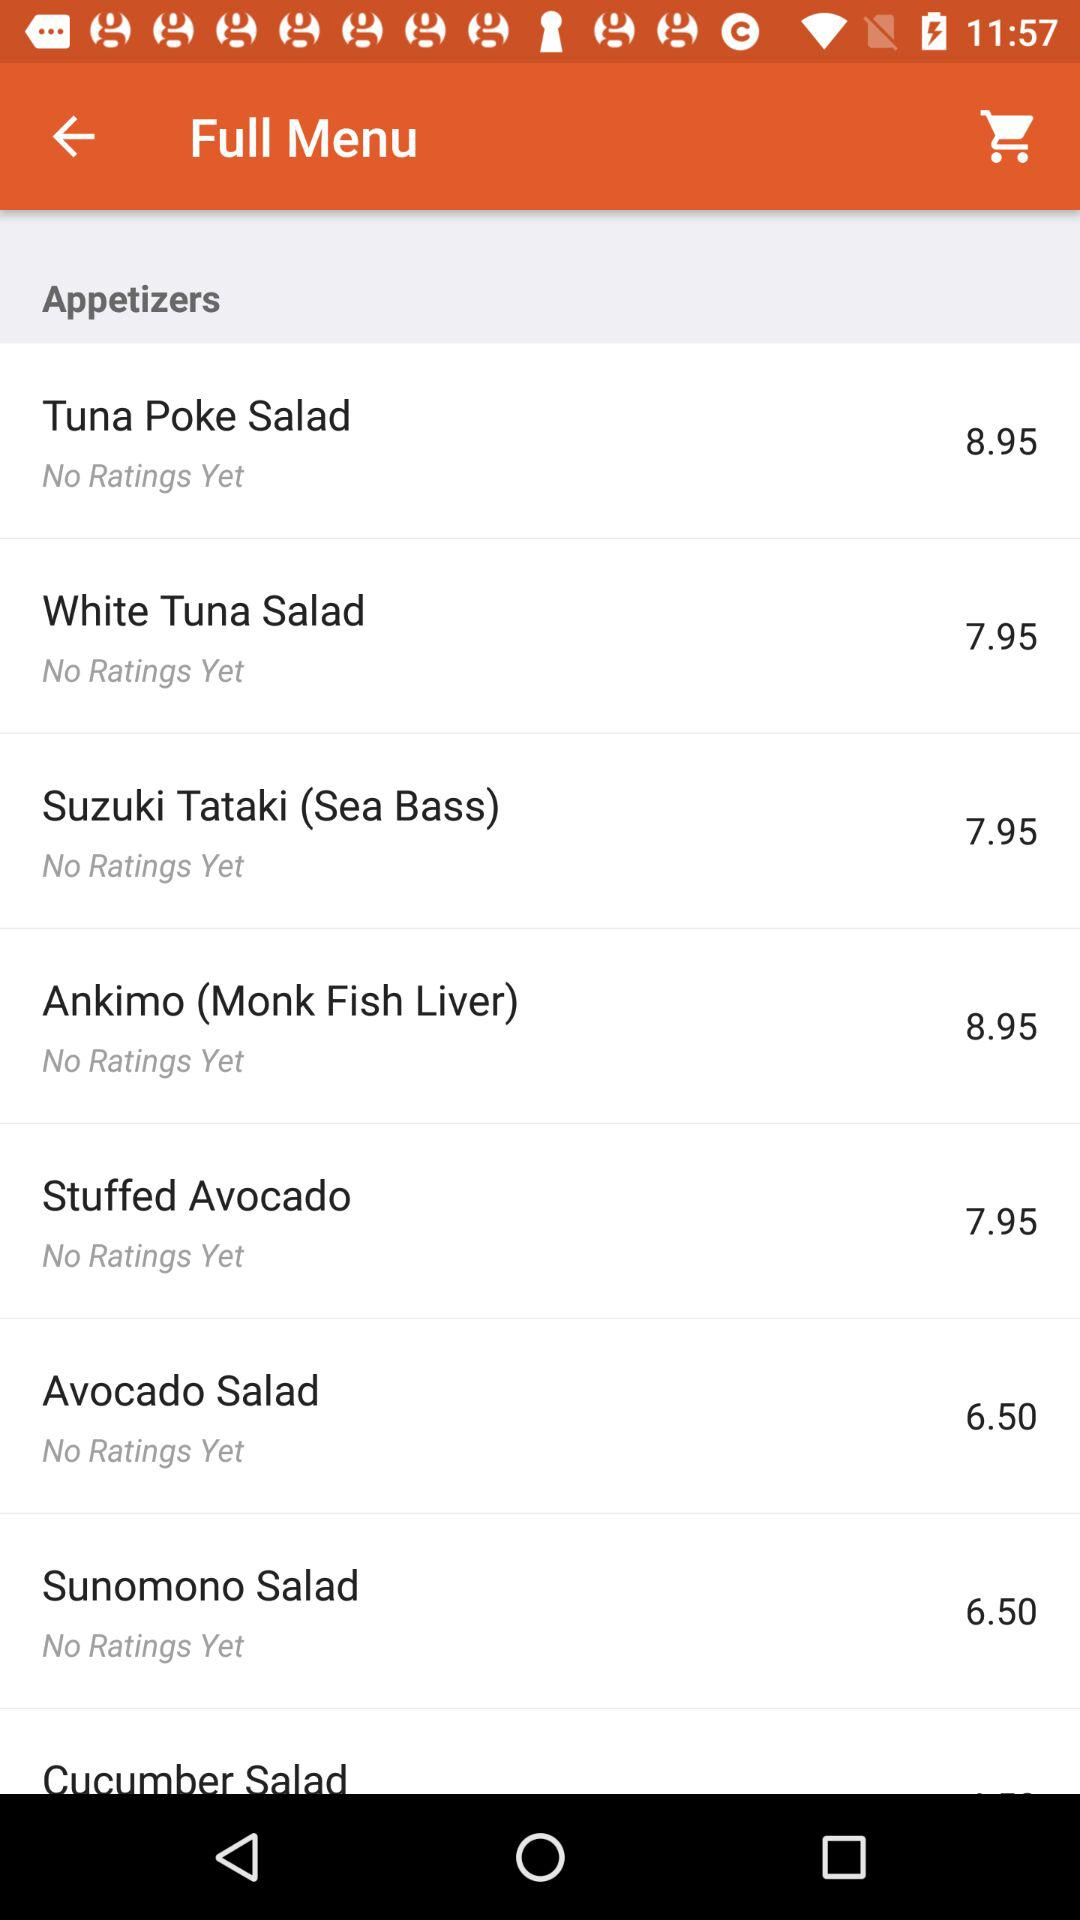What are the ratings for the sunomono salad? There are no ratings for the sunomono salad. 